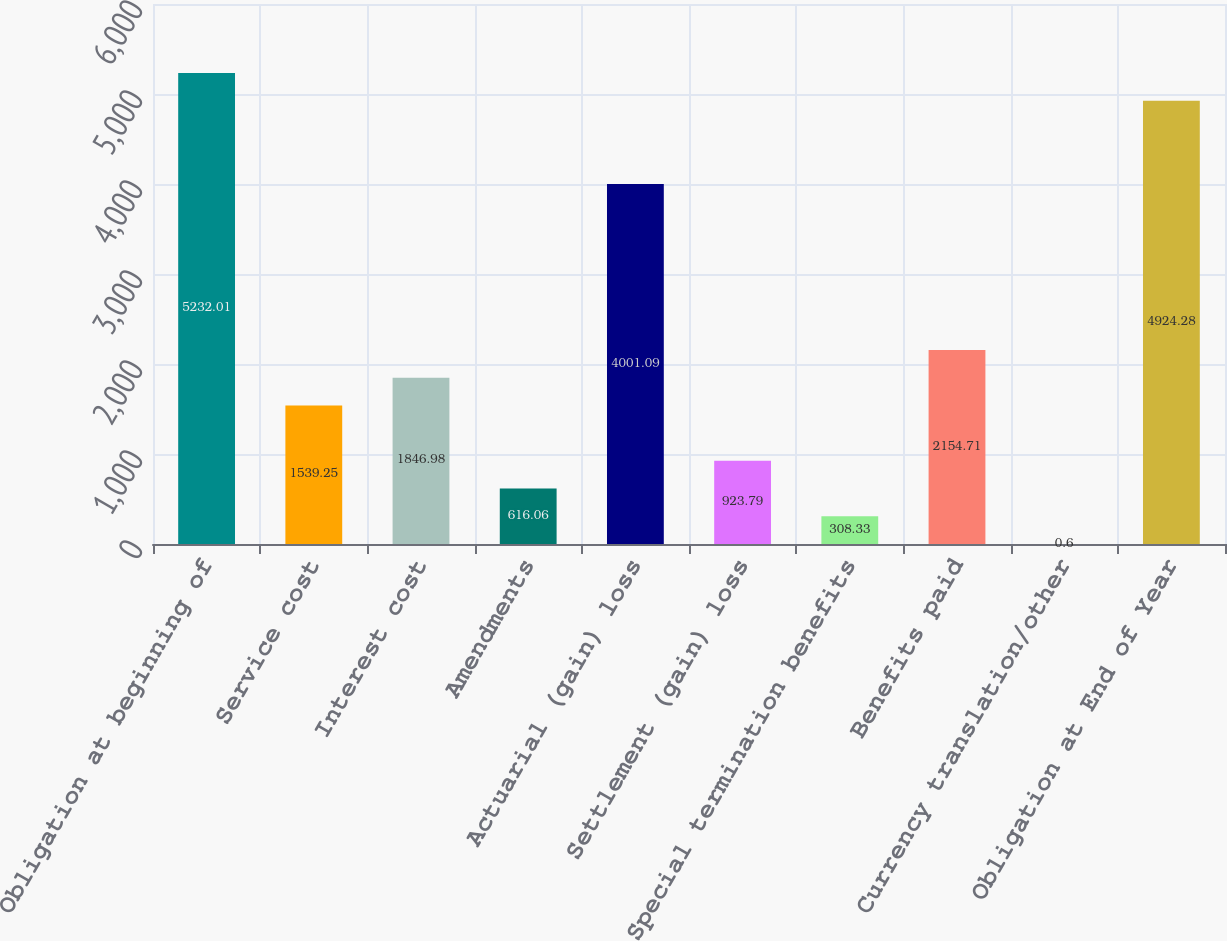Convert chart. <chart><loc_0><loc_0><loc_500><loc_500><bar_chart><fcel>Obligation at beginning of<fcel>Service cost<fcel>Interest cost<fcel>Amendments<fcel>Actuarial (gain) loss<fcel>Settlement (gain) loss<fcel>Special termination benefits<fcel>Benefits paid<fcel>Currency translation/other<fcel>Obligation at End of Year<nl><fcel>5232.01<fcel>1539.25<fcel>1846.98<fcel>616.06<fcel>4001.09<fcel>923.79<fcel>308.33<fcel>2154.71<fcel>0.6<fcel>4924.28<nl></chart> 